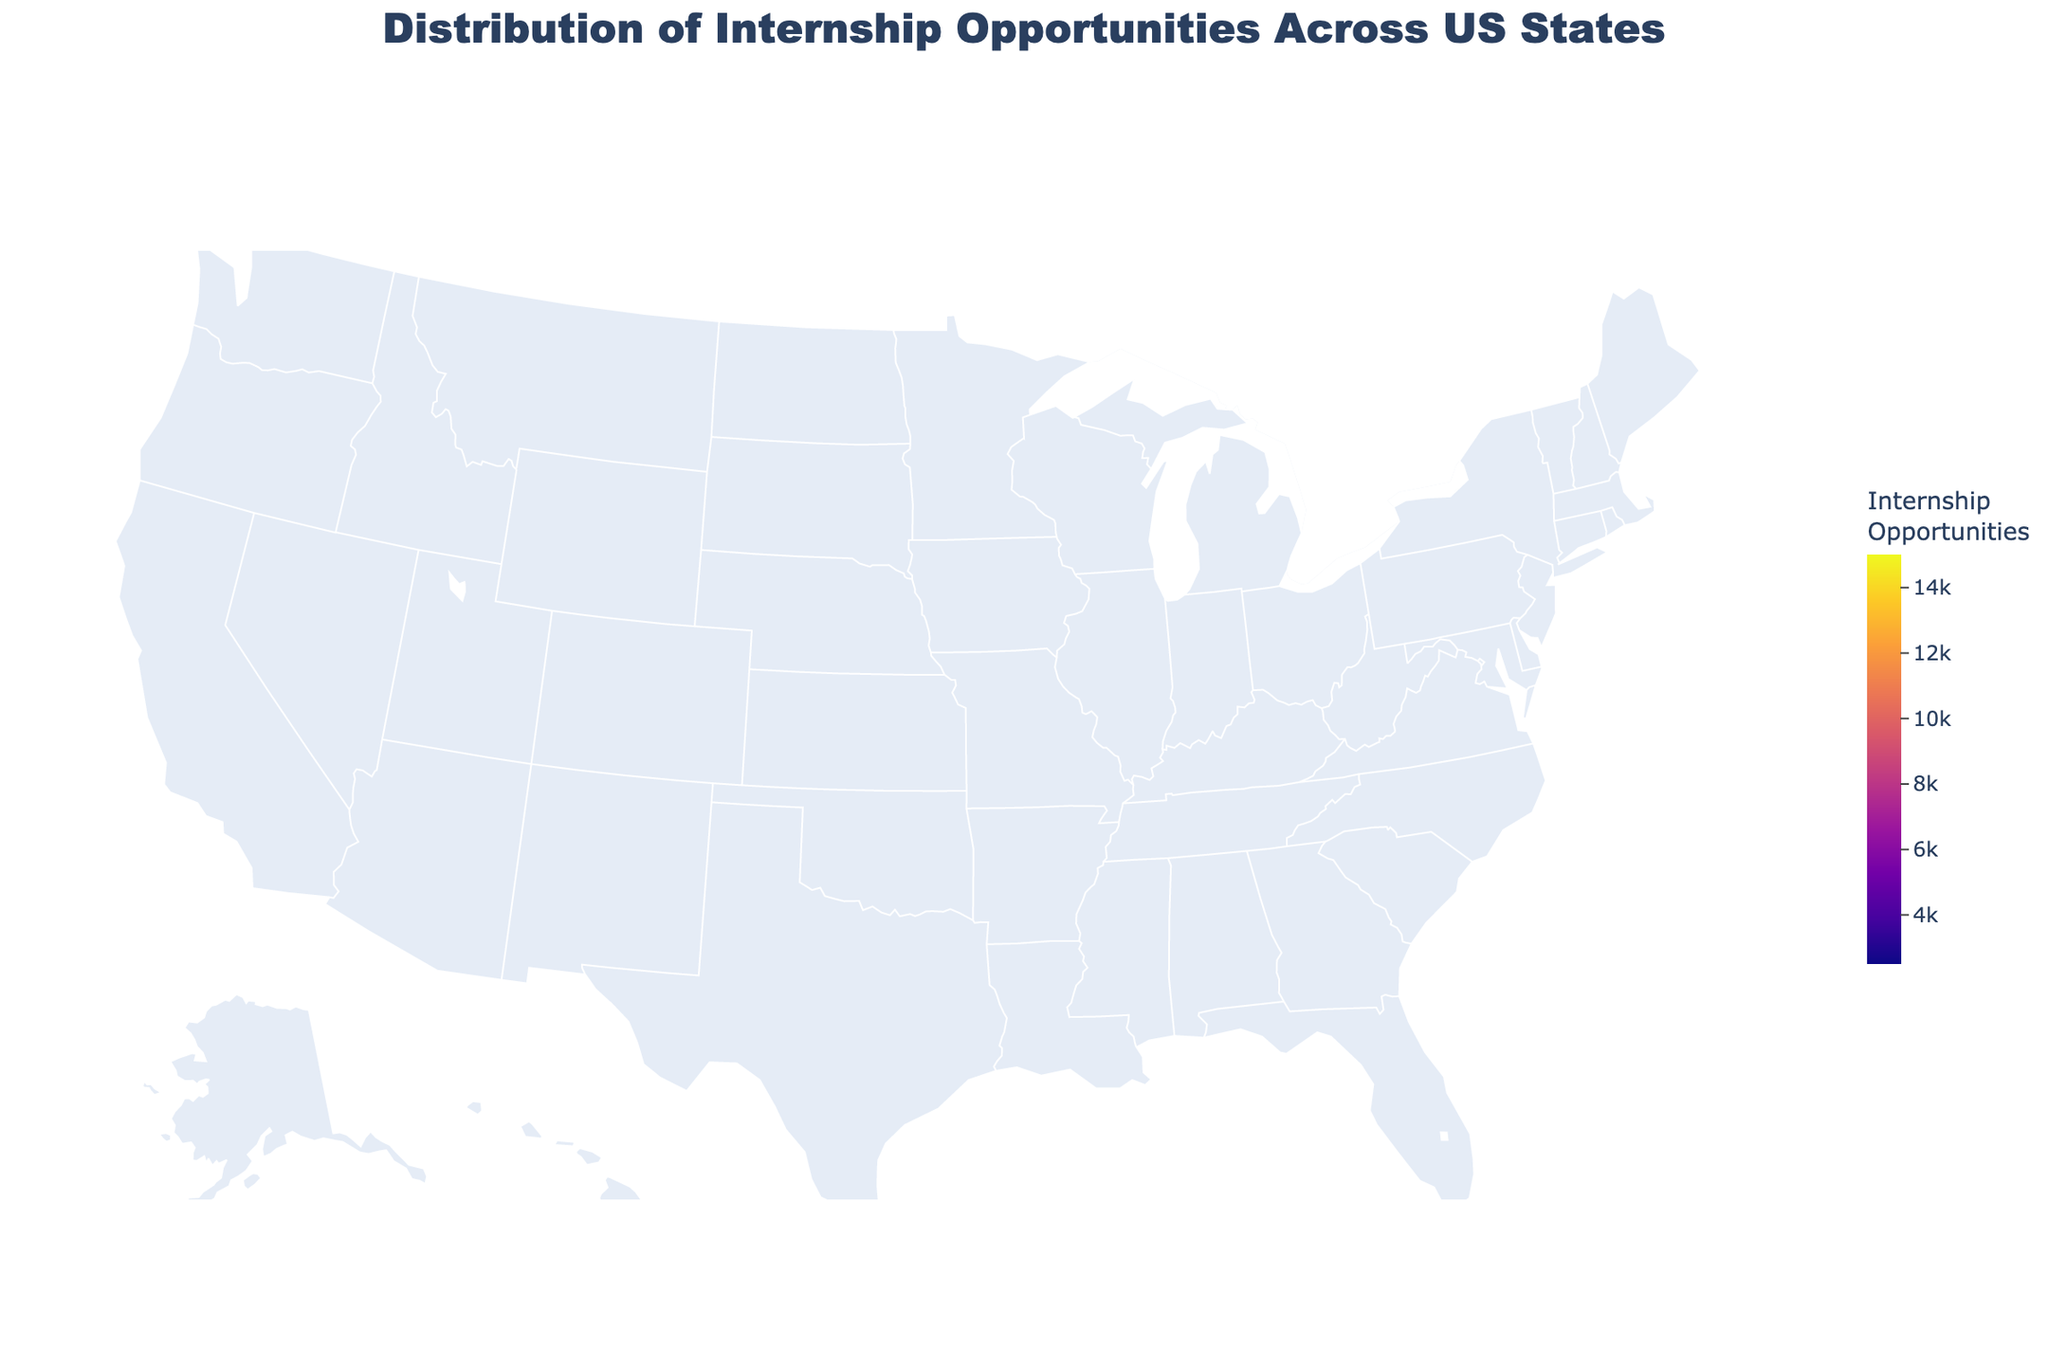What is the industry with the highest demand for internships in California? The figure shows each state labeled with the industry and number of internship opportunities. For California, the industry with the highest demand is Technology.
Answer: Technology Which state has the lowest number of internship opportunities? The figure highlights the number of internship opportunities for each state. New Jersey has the lowest number with 2,500 opportunities.
Answer: New Jersey What is the total number of internship opportunities for states with over 10,000 opportunities? From the figure, California has 15,000 and New York has 12,000 opportunities. Adding them gives 15,000 + 12,000 = 27,000 internship opportunities.
Answer: 27,000 Which states have internship opportunities between 5,000 and 7,000? The figure shows each state with color indicating the number of internship opportunities. Illinois (7,500), Washington (7,000), and Florida (6,500) fall in this range. However, consolidating to those clearly between 5,000 and 7,000 leaves us with Washington and Florida.
Answer: Washington, Florida What is the average number of internship opportunities across all states? Summing the internship opportunities for all states: 15,000 + 12,000 + 9,000 + 8,000 + 7,500 + 7,000 + 6,500 + 6,000 + 5,500 + 5,000 + 4,500 + 4,000 + 3,500 + 3,000 + 2,500 = 99,000. Dividing by the number of states (15) gives an average of 99,000 / 15 = 6,600.
Answer: 6,600 How does the number of internship opportunities in the Energy sector compare to the Biotechnology sector? Texas (Energy) has 9,000 opportunities while Massachusetts (Biotechnology) has 8,000 opportunities. Therefore, Energy has 1,000 more opportunities than Biotechnology.
Answer: Energy has 1,000 more Which state has the highest number of opportunities in the Tourism industry? The figure shows that Florida has the highest number of opportunities in the Tourism industry with 6,500 internships.
Answer: Florida Identify the state with the largest number of internship opportunities in Manufacturing. The figure indicates that Illinois has the highest number of Manufacturing internship opportunities with 7,500.
Answer: Illinois 